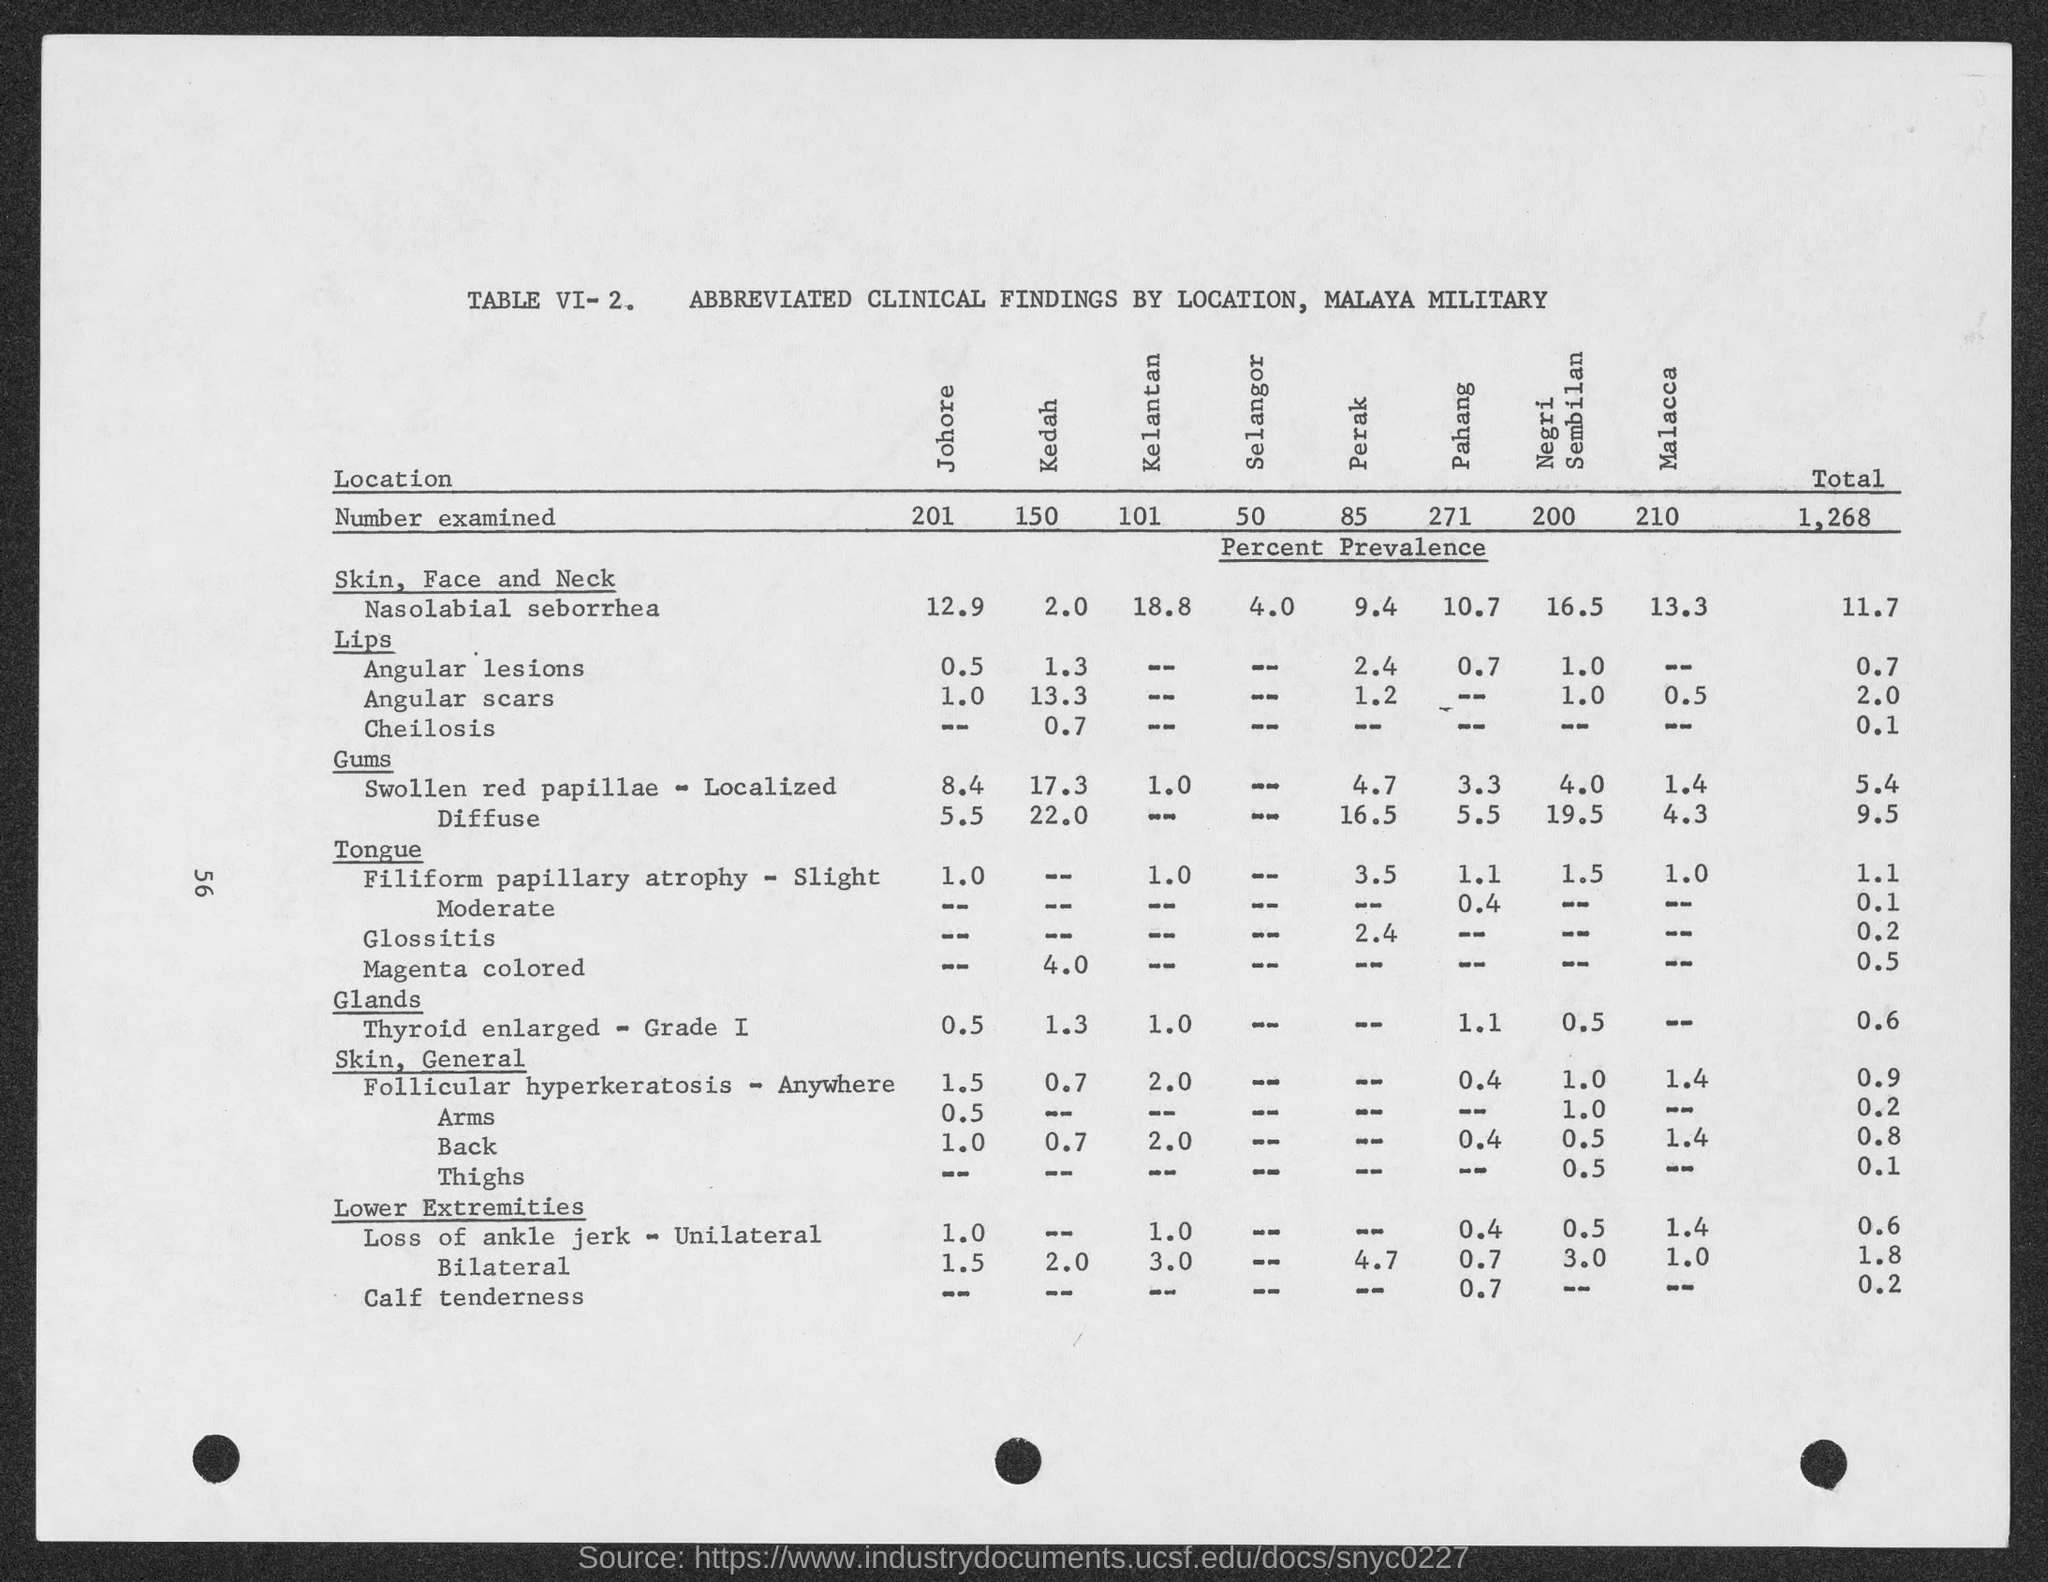Identify some key points in this picture. The number examined in Pahang is 271. The table number is VI-2. In Kelantan, a number has been examined that is 101... The number of exams conducted in Negri Sembilan is 200.. The number examined in Perak is 85. 